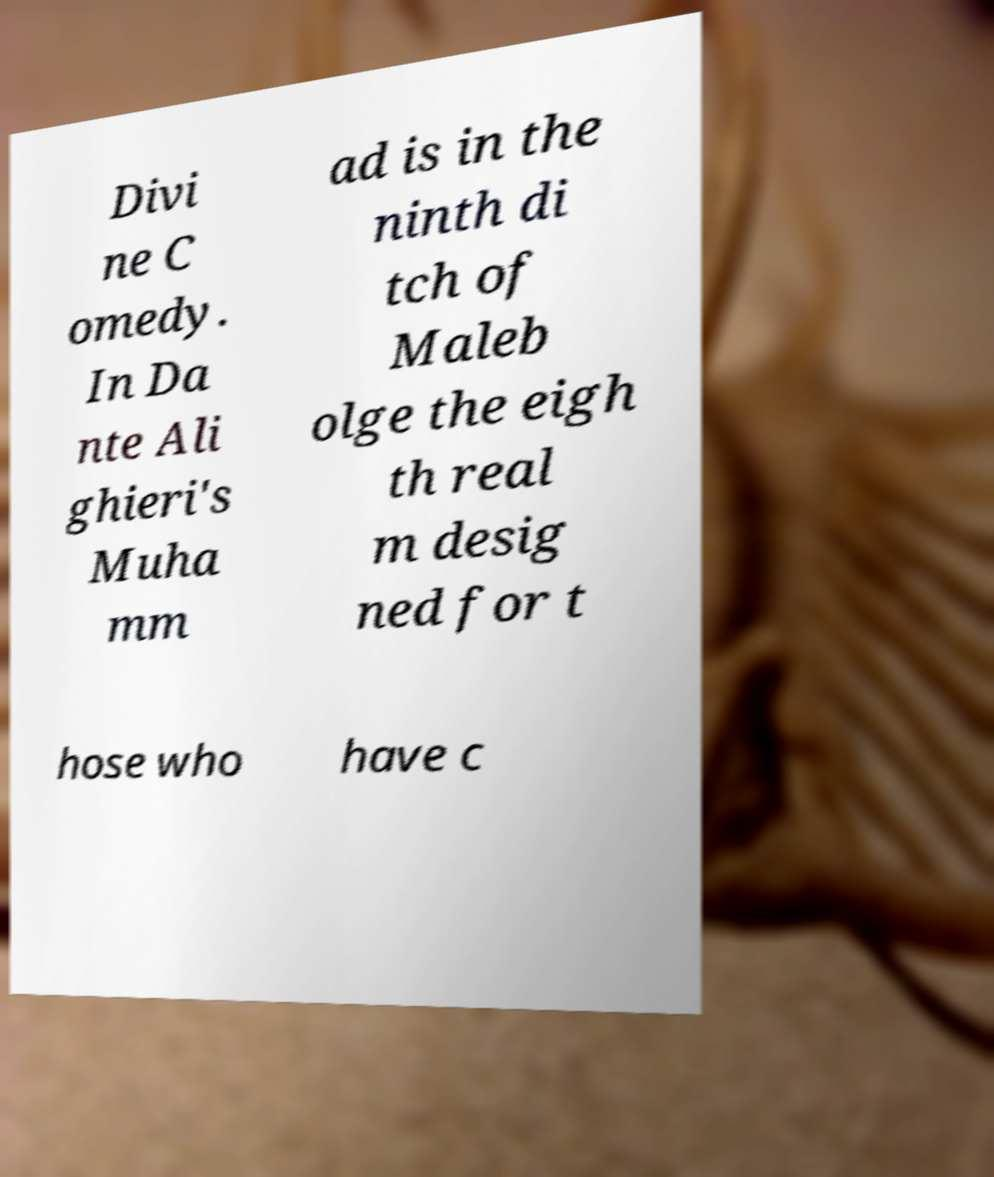Can you accurately transcribe the text from the provided image for me? Divi ne C omedy. In Da nte Ali ghieri's Muha mm ad is in the ninth di tch of Maleb olge the eigh th real m desig ned for t hose who have c 